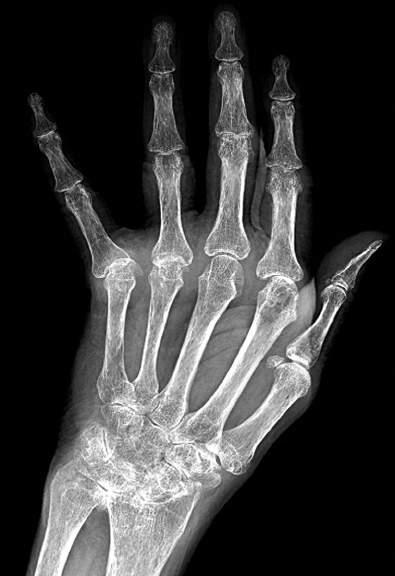do characteristic features include diffuse osteopenia, marked loss of the joint spaces of the carpal, metacarpal, phalangeal, and interphalangeal joints, periarticular bony erosions, and ulnar drift of the fingers?
Answer the question using a single word or phrase. Yes 